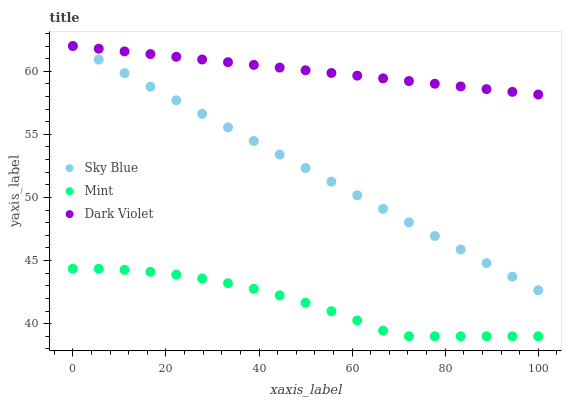Does Mint have the minimum area under the curve?
Answer yes or no. Yes. Does Dark Violet have the maximum area under the curve?
Answer yes or no. Yes. Does Dark Violet have the minimum area under the curve?
Answer yes or no. No. Does Mint have the maximum area under the curve?
Answer yes or no. No. Is Sky Blue the smoothest?
Answer yes or no. Yes. Is Mint the roughest?
Answer yes or no. Yes. Is Dark Violet the smoothest?
Answer yes or no. No. Is Dark Violet the roughest?
Answer yes or no. No. Does Mint have the lowest value?
Answer yes or no. Yes. Does Dark Violet have the lowest value?
Answer yes or no. No. Does Dark Violet have the highest value?
Answer yes or no. Yes. Does Mint have the highest value?
Answer yes or no. No. Is Mint less than Dark Violet?
Answer yes or no. Yes. Is Dark Violet greater than Mint?
Answer yes or no. Yes. Does Sky Blue intersect Dark Violet?
Answer yes or no. Yes. Is Sky Blue less than Dark Violet?
Answer yes or no. No. Is Sky Blue greater than Dark Violet?
Answer yes or no. No. Does Mint intersect Dark Violet?
Answer yes or no. No. 